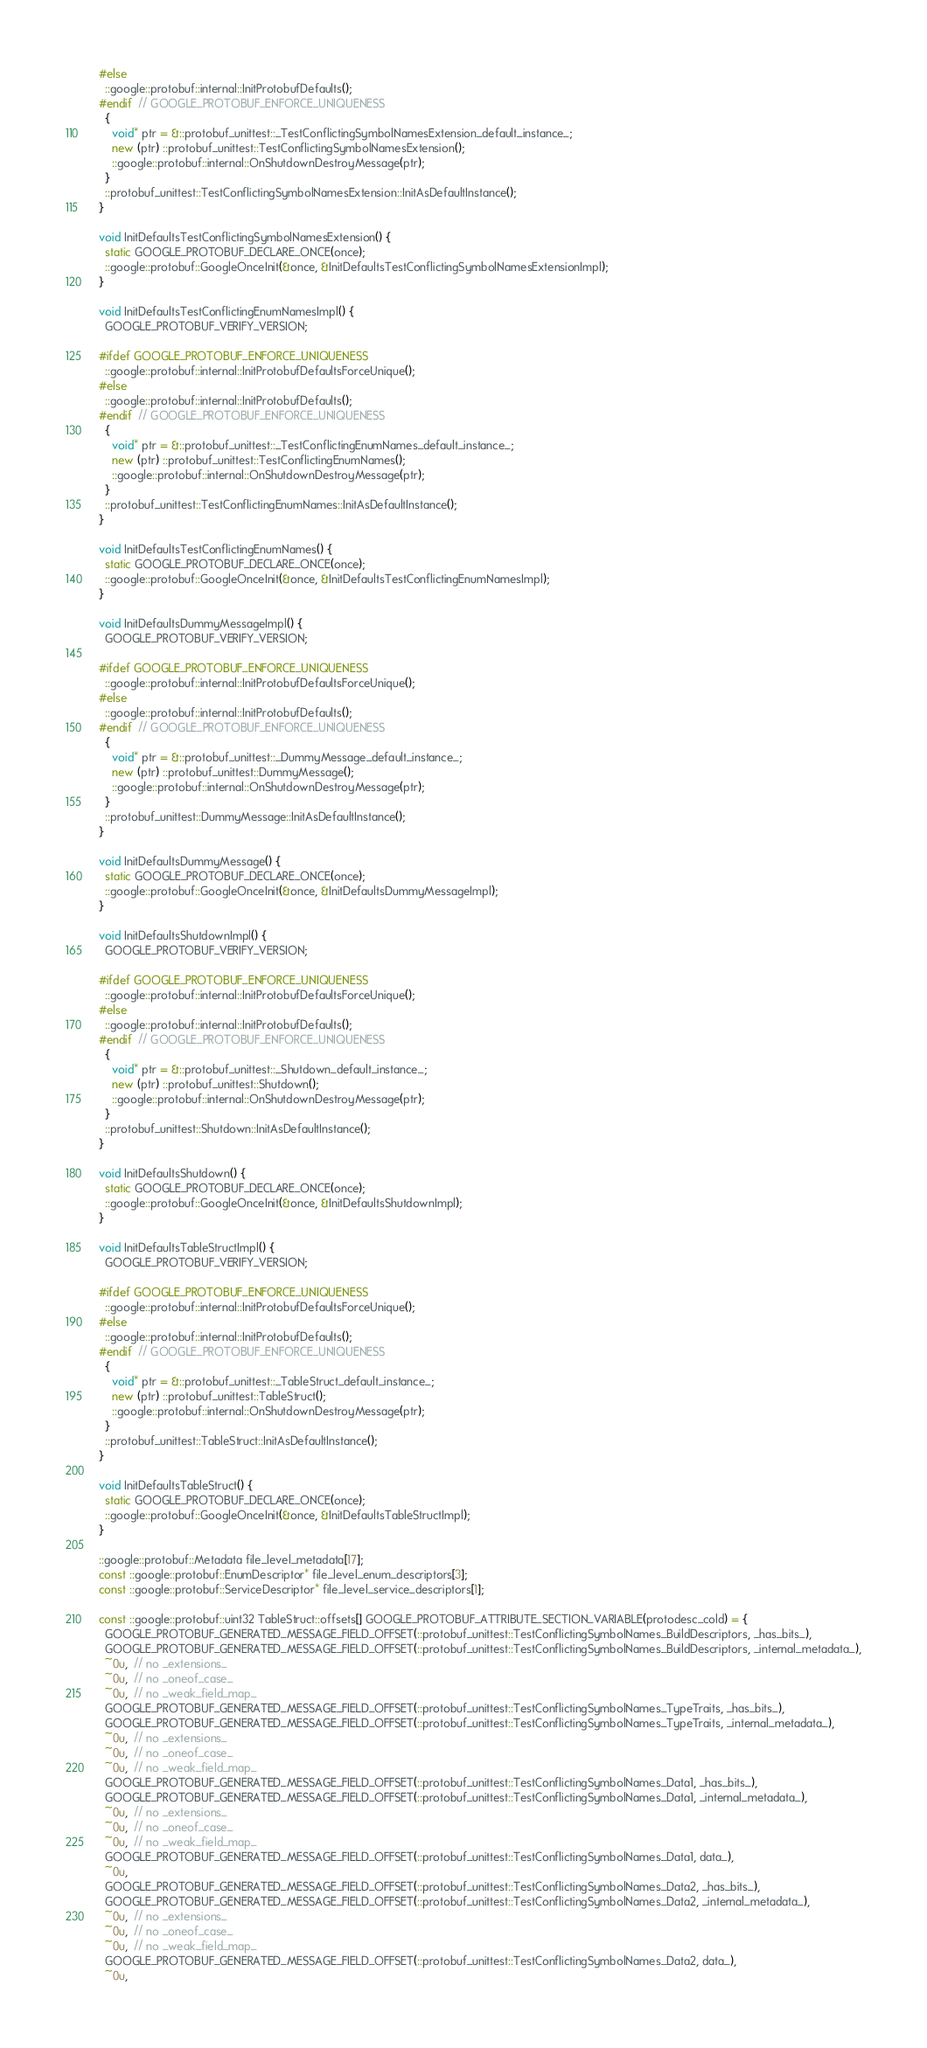<code> <loc_0><loc_0><loc_500><loc_500><_C++_>#else
  ::google::protobuf::internal::InitProtobufDefaults();
#endif  // GOOGLE_PROTOBUF_ENFORCE_UNIQUENESS
  {
    void* ptr = &::protobuf_unittest::_TestConflictingSymbolNamesExtension_default_instance_;
    new (ptr) ::protobuf_unittest::TestConflictingSymbolNamesExtension();
    ::google::protobuf::internal::OnShutdownDestroyMessage(ptr);
  }
  ::protobuf_unittest::TestConflictingSymbolNamesExtension::InitAsDefaultInstance();
}

void InitDefaultsTestConflictingSymbolNamesExtension() {
  static GOOGLE_PROTOBUF_DECLARE_ONCE(once);
  ::google::protobuf::GoogleOnceInit(&once, &InitDefaultsTestConflictingSymbolNamesExtensionImpl);
}

void InitDefaultsTestConflictingEnumNamesImpl() {
  GOOGLE_PROTOBUF_VERIFY_VERSION;

#ifdef GOOGLE_PROTOBUF_ENFORCE_UNIQUENESS
  ::google::protobuf::internal::InitProtobufDefaultsForceUnique();
#else
  ::google::protobuf::internal::InitProtobufDefaults();
#endif  // GOOGLE_PROTOBUF_ENFORCE_UNIQUENESS
  {
    void* ptr = &::protobuf_unittest::_TestConflictingEnumNames_default_instance_;
    new (ptr) ::protobuf_unittest::TestConflictingEnumNames();
    ::google::protobuf::internal::OnShutdownDestroyMessage(ptr);
  }
  ::protobuf_unittest::TestConflictingEnumNames::InitAsDefaultInstance();
}

void InitDefaultsTestConflictingEnumNames() {
  static GOOGLE_PROTOBUF_DECLARE_ONCE(once);
  ::google::protobuf::GoogleOnceInit(&once, &InitDefaultsTestConflictingEnumNamesImpl);
}

void InitDefaultsDummyMessageImpl() {
  GOOGLE_PROTOBUF_VERIFY_VERSION;

#ifdef GOOGLE_PROTOBUF_ENFORCE_UNIQUENESS
  ::google::protobuf::internal::InitProtobufDefaultsForceUnique();
#else
  ::google::protobuf::internal::InitProtobufDefaults();
#endif  // GOOGLE_PROTOBUF_ENFORCE_UNIQUENESS
  {
    void* ptr = &::protobuf_unittest::_DummyMessage_default_instance_;
    new (ptr) ::protobuf_unittest::DummyMessage();
    ::google::protobuf::internal::OnShutdownDestroyMessage(ptr);
  }
  ::protobuf_unittest::DummyMessage::InitAsDefaultInstance();
}

void InitDefaultsDummyMessage() {
  static GOOGLE_PROTOBUF_DECLARE_ONCE(once);
  ::google::protobuf::GoogleOnceInit(&once, &InitDefaultsDummyMessageImpl);
}

void InitDefaultsShutdownImpl() {
  GOOGLE_PROTOBUF_VERIFY_VERSION;

#ifdef GOOGLE_PROTOBUF_ENFORCE_UNIQUENESS
  ::google::protobuf::internal::InitProtobufDefaultsForceUnique();
#else
  ::google::protobuf::internal::InitProtobufDefaults();
#endif  // GOOGLE_PROTOBUF_ENFORCE_UNIQUENESS
  {
    void* ptr = &::protobuf_unittest::_Shutdown_default_instance_;
    new (ptr) ::protobuf_unittest::Shutdown();
    ::google::protobuf::internal::OnShutdownDestroyMessage(ptr);
  }
  ::protobuf_unittest::Shutdown::InitAsDefaultInstance();
}

void InitDefaultsShutdown() {
  static GOOGLE_PROTOBUF_DECLARE_ONCE(once);
  ::google::protobuf::GoogleOnceInit(&once, &InitDefaultsShutdownImpl);
}

void InitDefaultsTableStructImpl() {
  GOOGLE_PROTOBUF_VERIFY_VERSION;

#ifdef GOOGLE_PROTOBUF_ENFORCE_UNIQUENESS
  ::google::protobuf::internal::InitProtobufDefaultsForceUnique();
#else
  ::google::protobuf::internal::InitProtobufDefaults();
#endif  // GOOGLE_PROTOBUF_ENFORCE_UNIQUENESS
  {
    void* ptr = &::protobuf_unittest::_TableStruct_default_instance_;
    new (ptr) ::protobuf_unittest::TableStruct();
    ::google::protobuf::internal::OnShutdownDestroyMessage(ptr);
  }
  ::protobuf_unittest::TableStruct::InitAsDefaultInstance();
}

void InitDefaultsTableStruct() {
  static GOOGLE_PROTOBUF_DECLARE_ONCE(once);
  ::google::protobuf::GoogleOnceInit(&once, &InitDefaultsTableStructImpl);
}

::google::protobuf::Metadata file_level_metadata[17];
const ::google::protobuf::EnumDescriptor* file_level_enum_descriptors[3];
const ::google::protobuf::ServiceDescriptor* file_level_service_descriptors[1];

const ::google::protobuf::uint32 TableStruct::offsets[] GOOGLE_PROTOBUF_ATTRIBUTE_SECTION_VARIABLE(protodesc_cold) = {
  GOOGLE_PROTOBUF_GENERATED_MESSAGE_FIELD_OFFSET(::protobuf_unittest::TestConflictingSymbolNames_BuildDescriptors, _has_bits_),
  GOOGLE_PROTOBUF_GENERATED_MESSAGE_FIELD_OFFSET(::protobuf_unittest::TestConflictingSymbolNames_BuildDescriptors, _internal_metadata_),
  ~0u,  // no _extensions_
  ~0u,  // no _oneof_case_
  ~0u,  // no _weak_field_map_
  GOOGLE_PROTOBUF_GENERATED_MESSAGE_FIELD_OFFSET(::protobuf_unittest::TestConflictingSymbolNames_TypeTraits, _has_bits_),
  GOOGLE_PROTOBUF_GENERATED_MESSAGE_FIELD_OFFSET(::protobuf_unittest::TestConflictingSymbolNames_TypeTraits, _internal_metadata_),
  ~0u,  // no _extensions_
  ~0u,  // no _oneof_case_
  ~0u,  // no _weak_field_map_
  GOOGLE_PROTOBUF_GENERATED_MESSAGE_FIELD_OFFSET(::protobuf_unittest::TestConflictingSymbolNames_Data1, _has_bits_),
  GOOGLE_PROTOBUF_GENERATED_MESSAGE_FIELD_OFFSET(::protobuf_unittest::TestConflictingSymbolNames_Data1, _internal_metadata_),
  ~0u,  // no _extensions_
  ~0u,  // no _oneof_case_
  ~0u,  // no _weak_field_map_
  GOOGLE_PROTOBUF_GENERATED_MESSAGE_FIELD_OFFSET(::protobuf_unittest::TestConflictingSymbolNames_Data1, data_),
  ~0u,
  GOOGLE_PROTOBUF_GENERATED_MESSAGE_FIELD_OFFSET(::protobuf_unittest::TestConflictingSymbolNames_Data2, _has_bits_),
  GOOGLE_PROTOBUF_GENERATED_MESSAGE_FIELD_OFFSET(::protobuf_unittest::TestConflictingSymbolNames_Data2, _internal_metadata_),
  ~0u,  // no _extensions_
  ~0u,  // no _oneof_case_
  ~0u,  // no _weak_field_map_
  GOOGLE_PROTOBUF_GENERATED_MESSAGE_FIELD_OFFSET(::protobuf_unittest::TestConflictingSymbolNames_Data2, data_),
  ~0u,</code> 